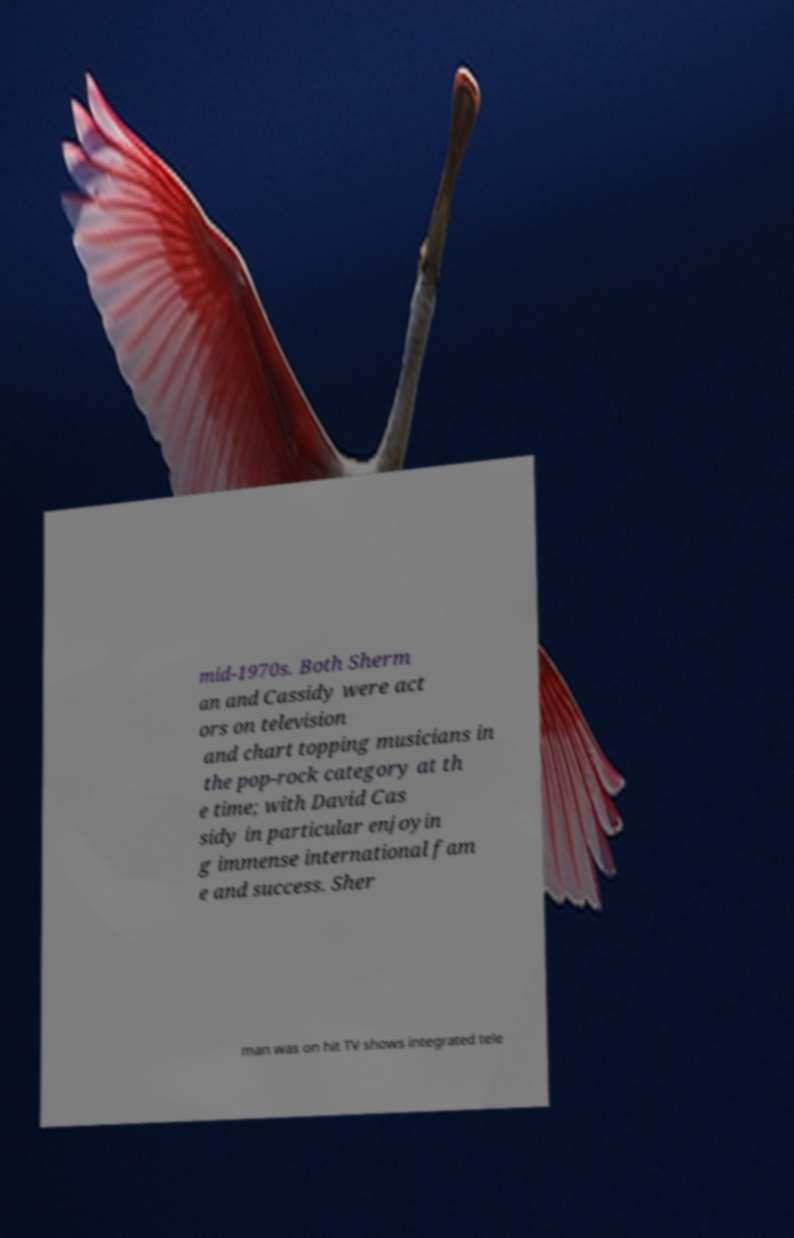Please read and relay the text visible in this image. What does it say? mid-1970s. Both Sherm an and Cassidy were act ors on television and chart topping musicians in the pop-rock category at th e time; with David Cas sidy in particular enjoyin g immense international fam e and success. Sher man was on hit TV shows integrated tele 